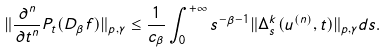Convert formula to latex. <formula><loc_0><loc_0><loc_500><loc_500>\| \frac { \partial ^ { n } } { \partial t ^ { n } } P _ { t } ( D _ { \beta } f ) \| _ { p , \gamma } \leq \frac { 1 } { c _ { \beta } } \int _ { 0 } ^ { + \infty } s ^ { - \beta - 1 } \| \Delta _ { s } ^ { k } ( u ^ { ( n ) } , t ) \| _ { p , \gamma } d s .</formula> 